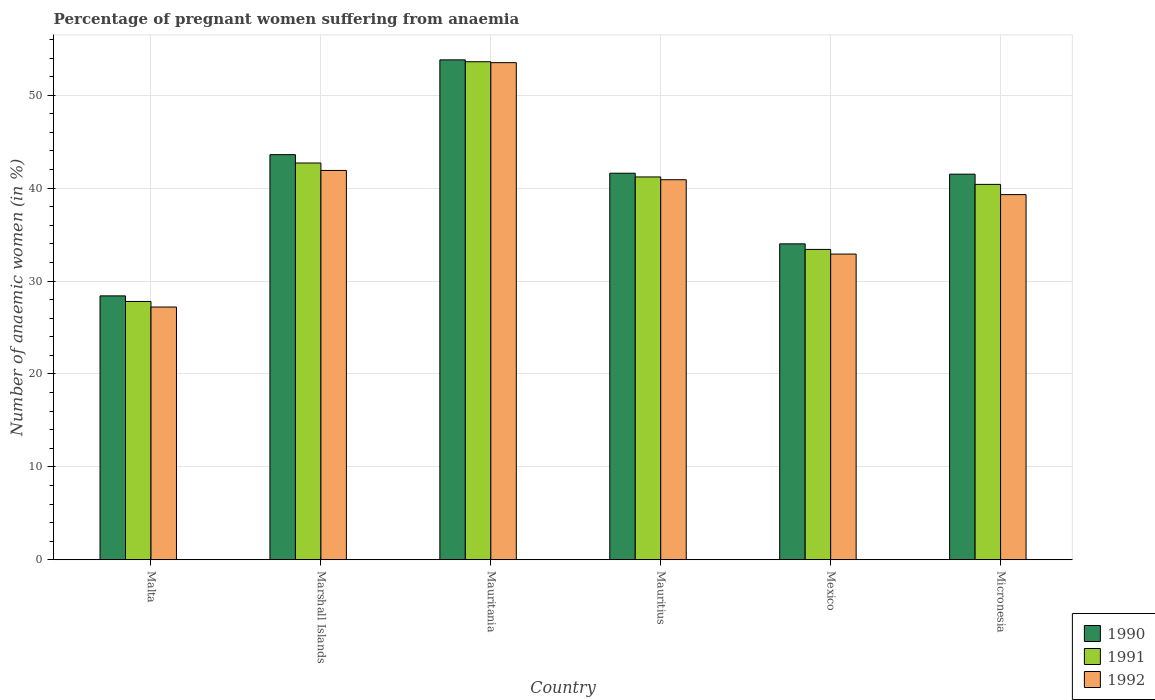How many different coloured bars are there?
Give a very brief answer. 3. Are the number of bars on each tick of the X-axis equal?
Provide a short and direct response. Yes. How many bars are there on the 6th tick from the right?
Ensure brevity in your answer.  3. What is the label of the 1st group of bars from the left?
Ensure brevity in your answer.  Malta. In how many cases, is the number of bars for a given country not equal to the number of legend labels?
Your response must be concise. 0. What is the number of anaemic women in 1991 in Micronesia?
Offer a very short reply. 40.4. Across all countries, what is the maximum number of anaemic women in 1990?
Make the answer very short. 53.8. Across all countries, what is the minimum number of anaemic women in 1992?
Give a very brief answer. 27.2. In which country was the number of anaemic women in 1991 maximum?
Offer a very short reply. Mauritania. In which country was the number of anaemic women in 1990 minimum?
Provide a short and direct response. Malta. What is the total number of anaemic women in 1992 in the graph?
Your answer should be compact. 235.7. What is the difference between the number of anaemic women in 1991 in Malta and that in Mauritius?
Your answer should be very brief. -13.4. What is the difference between the number of anaemic women in 1992 in Marshall Islands and the number of anaemic women in 1990 in Mauritius?
Offer a very short reply. 0.3. What is the average number of anaemic women in 1991 per country?
Offer a very short reply. 39.85. What is the difference between the number of anaemic women of/in 1990 and number of anaemic women of/in 1992 in Malta?
Ensure brevity in your answer.  1.2. In how many countries, is the number of anaemic women in 1991 greater than 40 %?
Your answer should be compact. 4. What is the ratio of the number of anaemic women in 1992 in Mexico to that in Micronesia?
Your response must be concise. 0.84. Is the difference between the number of anaemic women in 1990 in Malta and Marshall Islands greater than the difference between the number of anaemic women in 1992 in Malta and Marshall Islands?
Your answer should be very brief. No. What is the difference between the highest and the second highest number of anaemic women in 1991?
Give a very brief answer. -1.5. What is the difference between the highest and the lowest number of anaemic women in 1991?
Keep it short and to the point. 25.8. What does the 3rd bar from the left in Micronesia represents?
Your answer should be compact. 1992. What does the 2nd bar from the right in Mexico represents?
Your response must be concise. 1991. Are all the bars in the graph horizontal?
Your answer should be very brief. No. Does the graph contain any zero values?
Your answer should be very brief. No. How are the legend labels stacked?
Provide a short and direct response. Vertical. What is the title of the graph?
Provide a succinct answer. Percentage of pregnant women suffering from anaemia. What is the label or title of the X-axis?
Your answer should be compact. Country. What is the label or title of the Y-axis?
Offer a very short reply. Number of anaemic women (in %). What is the Number of anaemic women (in %) of 1990 in Malta?
Ensure brevity in your answer.  28.4. What is the Number of anaemic women (in %) of 1991 in Malta?
Your response must be concise. 27.8. What is the Number of anaemic women (in %) in 1992 in Malta?
Your answer should be compact. 27.2. What is the Number of anaemic women (in %) in 1990 in Marshall Islands?
Give a very brief answer. 43.6. What is the Number of anaemic women (in %) of 1991 in Marshall Islands?
Your answer should be very brief. 42.7. What is the Number of anaemic women (in %) in 1992 in Marshall Islands?
Keep it short and to the point. 41.9. What is the Number of anaemic women (in %) in 1990 in Mauritania?
Your answer should be very brief. 53.8. What is the Number of anaemic women (in %) in 1991 in Mauritania?
Your answer should be very brief. 53.6. What is the Number of anaemic women (in %) in 1992 in Mauritania?
Provide a succinct answer. 53.5. What is the Number of anaemic women (in %) of 1990 in Mauritius?
Provide a short and direct response. 41.6. What is the Number of anaemic women (in %) in 1991 in Mauritius?
Keep it short and to the point. 41.2. What is the Number of anaemic women (in %) in 1992 in Mauritius?
Offer a terse response. 40.9. What is the Number of anaemic women (in %) of 1990 in Mexico?
Your response must be concise. 34. What is the Number of anaemic women (in %) in 1991 in Mexico?
Offer a very short reply. 33.4. What is the Number of anaemic women (in %) in 1992 in Mexico?
Offer a terse response. 32.9. What is the Number of anaemic women (in %) in 1990 in Micronesia?
Keep it short and to the point. 41.5. What is the Number of anaemic women (in %) of 1991 in Micronesia?
Your response must be concise. 40.4. What is the Number of anaemic women (in %) in 1992 in Micronesia?
Keep it short and to the point. 39.3. Across all countries, what is the maximum Number of anaemic women (in %) of 1990?
Your answer should be compact. 53.8. Across all countries, what is the maximum Number of anaemic women (in %) in 1991?
Make the answer very short. 53.6. Across all countries, what is the maximum Number of anaemic women (in %) in 1992?
Keep it short and to the point. 53.5. Across all countries, what is the minimum Number of anaemic women (in %) in 1990?
Your answer should be compact. 28.4. Across all countries, what is the minimum Number of anaemic women (in %) of 1991?
Your answer should be very brief. 27.8. Across all countries, what is the minimum Number of anaemic women (in %) in 1992?
Provide a succinct answer. 27.2. What is the total Number of anaemic women (in %) in 1990 in the graph?
Offer a very short reply. 242.9. What is the total Number of anaemic women (in %) of 1991 in the graph?
Make the answer very short. 239.1. What is the total Number of anaemic women (in %) in 1992 in the graph?
Offer a terse response. 235.7. What is the difference between the Number of anaemic women (in %) in 1990 in Malta and that in Marshall Islands?
Make the answer very short. -15.2. What is the difference between the Number of anaemic women (in %) of 1991 in Malta and that in Marshall Islands?
Offer a very short reply. -14.9. What is the difference between the Number of anaemic women (in %) in 1992 in Malta and that in Marshall Islands?
Make the answer very short. -14.7. What is the difference between the Number of anaemic women (in %) of 1990 in Malta and that in Mauritania?
Provide a succinct answer. -25.4. What is the difference between the Number of anaemic women (in %) of 1991 in Malta and that in Mauritania?
Your answer should be very brief. -25.8. What is the difference between the Number of anaemic women (in %) of 1992 in Malta and that in Mauritania?
Your answer should be compact. -26.3. What is the difference between the Number of anaemic women (in %) of 1992 in Malta and that in Mauritius?
Your answer should be compact. -13.7. What is the difference between the Number of anaemic women (in %) in 1990 in Malta and that in Mexico?
Give a very brief answer. -5.6. What is the difference between the Number of anaemic women (in %) in 1991 in Malta and that in Mexico?
Your answer should be very brief. -5.6. What is the difference between the Number of anaemic women (in %) of 1992 in Malta and that in Mexico?
Provide a short and direct response. -5.7. What is the difference between the Number of anaemic women (in %) of 1991 in Malta and that in Micronesia?
Provide a succinct answer. -12.6. What is the difference between the Number of anaemic women (in %) in 1992 in Marshall Islands and that in Mauritania?
Ensure brevity in your answer.  -11.6. What is the difference between the Number of anaemic women (in %) in 1991 in Marshall Islands and that in Mauritius?
Keep it short and to the point. 1.5. What is the difference between the Number of anaemic women (in %) of 1992 in Marshall Islands and that in Mauritius?
Make the answer very short. 1. What is the difference between the Number of anaemic women (in %) in 1990 in Marshall Islands and that in Mexico?
Ensure brevity in your answer.  9.6. What is the difference between the Number of anaemic women (in %) of 1991 in Marshall Islands and that in Mexico?
Offer a very short reply. 9.3. What is the difference between the Number of anaemic women (in %) of 1990 in Marshall Islands and that in Micronesia?
Offer a very short reply. 2.1. What is the difference between the Number of anaemic women (in %) in 1991 in Marshall Islands and that in Micronesia?
Provide a short and direct response. 2.3. What is the difference between the Number of anaemic women (in %) in 1990 in Mauritania and that in Mauritius?
Make the answer very short. 12.2. What is the difference between the Number of anaemic women (in %) in 1991 in Mauritania and that in Mauritius?
Provide a succinct answer. 12.4. What is the difference between the Number of anaemic women (in %) in 1992 in Mauritania and that in Mauritius?
Provide a succinct answer. 12.6. What is the difference between the Number of anaemic women (in %) in 1990 in Mauritania and that in Mexico?
Offer a terse response. 19.8. What is the difference between the Number of anaemic women (in %) in 1991 in Mauritania and that in Mexico?
Offer a very short reply. 20.2. What is the difference between the Number of anaemic women (in %) in 1992 in Mauritania and that in Mexico?
Your answer should be compact. 20.6. What is the difference between the Number of anaemic women (in %) of 1991 in Mauritius and that in Micronesia?
Your answer should be very brief. 0.8. What is the difference between the Number of anaemic women (in %) in 1992 in Mauritius and that in Micronesia?
Offer a very short reply. 1.6. What is the difference between the Number of anaemic women (in %) of 1990 in Mexico and that in Micronesia?
Offer a terse response. -7.5. What is the difference between the Number of anaemic women (in %) in 1991 in Mexico and that in Micronesia?
Your response must be concise. -7. What is the difference between the Number of anaemic women (in %) in 1992 in Mexico and that in Micronesia?
Your answer should be compact. -6.4. What is the difference between the Number of anaemic women (in %) in 1990 in Malta and the Number of anaemic women (in %) in 1991 in Marshall Islands?
Ensure brevity in your answer.  -14.3. What is the difference between the Number of anaemic women (in %) of 1991 in Malta and the Number of anaemic women (in %) of 1992 in Marshall Islands?
Offer a very short reply. -14.1. What is the difference between the Number of anaemic women (in %) of 1990 in Malta and the Number of anaemic women (in %) of 1991 in Mauritania?
Offer a terse response. -25.2. What is the difference between the Number of anaemic women (in %) in 1990 in Malta and the Number of anaemic women (in %) in 1992 in Mauritania?
Keep it short and to the point. -25.1. What is the difference between the Number of anaemic women (in %) of 1991 in Malta and the Number of anaemic women (in %) of 1992 in Mauritania?
Your response must be concise. -25.7. What is the difference between the Number of anaemic women (in %) of 1990 in Malta and the Number of anaemic women (in %) of 1991 in Mauritius?
Offer a terse response. -12.8. What is the difference between the Number of anaemic women (in %) of 1990 in Malta and the Number of anaemic women (in %) of 1992 in Mauritius?
Your response must be concise. -12.5. What is the difference between the Number of anaemic women (in %) of 1991 in Malta and the Number of anaemic women (in %) of 1992 in Mauritius?
Make the answer very short. -13.1. What is the difference between the Number of anaemic women (in %) of 1990 in Malta and the Number of anaemic women (in %) of 1991 in Mexico?
Ensure brevity in your answer.  -5. What is the difference between the Number of anaemic women (in %) of 1990 in Malta and the Number of anaemic women (in %) of 1992 in Mexico?
Provide a succinct answer. -4.5. What is the difference between the Number of anaemic women (in %) in 1990 in Malta and the Number of anaemic women (in %) in 1992 in Micronesia?
Ensure brevity in your answer.  -10.9. What is the difference between the Number of anaemic women (in %) in 1991 in Marshall Islands and the Number of anaemic women (in %) in 1992 in Mauritania?
Provide a succinct answer. -10.8. What is the difference between the Number of anaemic women (in %) in 1990 in Marshall Islands and the Number of anaemic women (in %) in 1992 in Mauritius?
Your response must be concise. 2.7. What is the difference between the Number of anaemic women (in %) of 1991 in Marshall Islands and the Number of anaemic women (in %) of 1992 in Mauritius?
Provide a short and direct response. 1.8. What is the difference between the Number of anaemic women (in %) of 1990 in Marshall Islands and the Number of anaemic women (in %) of 1991 in Mexico?
Offer a terse response. 10.2. What is the difference between the Number of anaemic women (in %) in 1991 in Marshall Islands and the Number of anaemic women (in %) in 1992 in Mexico?
Offer a terse response. 9.8. What is the difference between the Number of anaemic women (in %) in 1990 in Marshall Islands and the Number of anaemic women (in %) in 1991 in Micronesia?
Provide a short and direct response. 3.2. What is the difference between the Number of anaemic women (in %) in 1990 in Marshall Islands and the Number of anaemic women (in %) in 1992 in Micronesia?
Provide a short and direct response. 4.3. What is the difference between the Number of anaemic women (in %) of 1991 in Marshall Islands and the Number of anaemic women (in %) of 1992 in Micronesia?
Ensure brevity in your answer.  3.4. What is the difference between the Number of anaemic women (in %) of 1990 in Mauritania and the Number of anaemic women (in %) of 1991 in Mexico?
Keep it short and to the point. 20.4. What is the difference between the Number of anaemic women (in %) of 1990 in Mauritania and the Number of anaemic women (in %) of 1992 in Mexico?
Your answer should be compact. 20.9. What is the difference between the Number of anaemic women (in %) in 1991 in Mauritania and the Number of anaemic women (in %) in 1992 in Mexico?
Make the answer very short. 20.7. What is the difference between the Number of anaemic women (in %) in 1990 in Mauritania and the Number of anaemic women (in %) in 1991 in Micronesia?
Offer a terse response. 13.4. What is the difference between the Number of anaemic women (in %) in 1990 in Mauritania and the Number of anaemic women (in %) in 1992 in Micronesia?
Make the answer very short. 14.5. What is the difference between the Number of anaemic women (in %) in 1990 in Mauritius and the Number of anaemic women (in %) in 1991 in Mexico?
Provide a succinct answer. 8.2. What is the difference between the Number of anaemic women (in %) of 1990 in Mauritius and the Number of anaemic women (in %) of 1991 in Micronesia?
Your response must be concise. 1.2. What is the difference between the Number of anaemic women (in %) in 1990 in Mauritius and the Number of anaemic women (in %) in 1992 in Micronesia?
Your answer should be compact. 2.3. What is the difference between the Number of anaemic women (in %) of 1991 in Mauritius and the Number of anaemic women (in %) of 1992 in Micronesia?
Make the answer very short. 1.9. What is the average Number of anaemic women (in %) of 1990 per country?
Give a very brief answer. 40.48. What is the average Number of anaemic women (in %) in 1991 per country?
Your answer should be very brief. 39.85. What is the average Number of anaemic women (in %) of 1992 per country?
Keep it short and to the point. 39.28. What is the difference between the Number of anaemic women (in %) of 1990 and Number of anaemic women (in %) of 1991 in Malta?
Make the answer very short. 0.6. What is the difference between the Number of anaemic women (in %) of 1990 and Number of anaemic women (in %) of 1992 in Malta?
Ensure brevity in your answer.  1.2. What is the difference between the Number of anaemic women (in %) in 1990 and Number of anaemic women (in %) in 1992 in Marshall Islands?
Provide a succinct answer. 1.7. What is the difference between the Number of anaemic women (in %) in 1990 and Number of anaemic women (in %) in 1991 in Mauritania?
Provide a succinct answer. 0.2. What is the difference between the Number of anaemic women (in %) in 1990 and Number of anaemic women (in %) in 1992 in Mauritania?
Provide a succinct answer. 0.3. What is the difference between the Number of anaemic women (in %) in 1991 and Number of anaemic women (in %) in 1992 in Mauritania?
Give a very brief answer. 0.1. What is the difference between the Number of anaemic women (in %) in 1990 and Number of anaemic women (in %) in 1991 in Mexico?
Ensure brevity in your answer.  0.6. What is the difference between the Number of anaemic women (in %) of 1990 and Number of anaemic women (in %) of 1992 in Mexico?
Your answer should be compact. 1.1. What is the difference between the Number of anaemic women (in %) of 1991 and Number of anaemic women (in %) of 1992 in Micronesia?
Your answer should be compact. 1.1. What is the ratio of the Number of anaemic women (in %) of 1990 in Malta to that in Marshall Islands?
Ensure brevity in your answer.  0.65. What is the ratio of the Number of anaemic women (in %) of 1991 in Malta to that in Marshall Islands?
Offer a very short reply. 0.65. What is the ratio of the Number of anaemic women (in %) of 1992 in Malta to that in Marshall Islands?
Offer a terse response. 0.65. What is the ratio of the Number of anaemic women (in %) of 1990 in Malta to that in Mauritania?
Provide a short and direct response. 0.53. What is the ratio of the Number of anaemic women (in %) of 1991 in Malta to that in Mauritania?
Give a very brief answer. 0.52. What is the ratio of the Number of anaemic women (in %) in 1992 in Malta to that in Mauritania?
Give a very brief answer. 0.51. What is the ratio of the Number of anaemic women (in %) in 1990 in Malta to that in Mauritius?
Keep it short and to the point. 0.68. What is the ratio of the Number of anaemic women (in %) in 1991 in Malta to that in Mauritius?
Provide a succinct answer. 0.67. What is the ratio of the Number of anaemic women (in %) of 1992 in Malta to that in Mauritius?
Your answer should be very brief. 0.67. What is the ratio of the Number of anaemic women (in %) of 1990 in Malta to that in Mexico?
Your response must be concise. 0.84. What is the ratio of the Number of anaemic women (in %) of 1991 in Malta to that in Mexico?
Provide a short and direct response. 0.83. What is the ratio of the Number of anaemic women (in %) of 1992 in Malta to that in Mexico?
Ensure brevity in your answer.  0.83. What is the ratio of the Number of anaemic women (in %) of 1990 in Malta to that in Micronesia?
Your answer should be very brief. 0.68. What is the ratio of the Number of anaemic women (in %) in 1991 in Malta to that in Micronesia?
Offer a very short reply. 0.69. What is the ratio of the Number of anaemic women (in %) of 1992 in Malta to that in Micronesia?
Your answer should be compact. 0.69. What is the ratio of the Number of anaemic women (in %) in 1990 in Marshall Islands to that in Mauritania?
Provide a short and direct response. 0.81. What is the ratio of the Number of anaemic women (in %) in 1991 in Marshall Islands to that in Mauritania?
Your answer should be very brief. 0.8. What is the ratio of the Number of anaemic women (in %) in 1992 in Marshall Islands to that in Mauritania?
Give a very brief answer. 0.78. What is the ratio of the Number of anaemic women (in %) of 1990 in Marshall Islands to that in Mauritius?
Keep it short and to the point. 1.05. What is the ratio of the Number of anaemic women (in %) in 1991 in Marshall Islands to that in Mauritius?
Offer a very short reply. 1.04. What is the ratio of the Number of anaemic women (in %) in 1992 in Marshall Islands to that in Mauritius?
Offer a terse response. 1.02. What is the ratio of the Number of anaemic women (in %) in 1990 in Marshall Islands to that in Mexico?
Your answer should be very brief. 1.28. What is the ratio of the Number of anaemic women (in %) of 1991 in Marshall Islands to that in Mexico?
Make the answer very short. 1.28. What is the ratio of the Number of anaemic women (in %) of 1992 in Marshall Islands to that in Mexico?
Ensure brevity in your answer.  1.27. What is the ratio of the Number of anaemic women (in %) of 1990 in Marshall Islands to that in Micronesia?
Your response must be concise. 1.05. What is the ratio of the Number of anaemic women (in %) of 1991 in Marshall Islands to that in Micronesia?
Your response must be concise. 1.06. What is the ratio of the Number of anaemic women (in %) in 1992 in Marshall Islands to that in Micronesia?
Ensure brevity in your answer.  1.07. What is the ratio of the Number of anaemic women (in %) in 1990 in Mauritania to that in Mauritius?
Provide a short and direct response. 1.29. What is the ratio of the Number of anaemic women (in %) in 1991 in Mauritania to that in Mauritius?
Provide a short and direct response. 1.3. What is the ratio of the Number of anaemic women (in %) in 1992 in Mauritania to that in Mauritius?
Ensure brevity in your answer.  1.31. What is the ratio of the Number of anaemic women (in %) in 1990 in Mauritania to that in Mexico?
Ensure brevity in your answer.  1.58. What is the ratio of the Number of anaemic women (in %) of 1991 in Mauritania to that in Mexico?
Make the answer very short. 1.6. What is the ratio of the Number of anaemic women (in %) of 1992 in Mauritania to that in Mexico?
Offer a terse response. 1.63. What is the ratio of the Number of anaemic women (in %) in 1990 in Mauritania to that in Micronesia?
Give a very brief answer. 1.3. What is the ratio of the Number of anaemic women (in %) of 1991 in Mauritania to that in Micronesia?
Ensure brevity in your answer.  1.33. What is the ratio of the Number of anaemic women (in %) in 1992 in Mauritania to that in Micronesia?
Give a very brief answer. 1.36. What is the ratio of the Number of anaemic women (in %) of 1990 in Mauritius to that in Mexico?
Give a very brief answer. 1.22. What is the ratio of the Number of anaemic women (in %) in 1991 in Mauritius to that in Mexico?
Offer a terse response. 1.23. What is the ratio of the Number of anaemic women (in %) in 1992 in Mauritius to that in Mexico?
Your answer should be compact. 1.24. What is the ratio of the Number of anaemic women (in %) of 1990 in Mauritius to that in Micronesia?
Ensure brevity in your answer.  1. What is the ratio of the Number of anaemic women (in %) in 1991 in Mauritius to that in Micronesia?
Provide a succinct answer. 1.02. What is the ratio of the Number of anaemic women (in %) of 1992 in Mauritius to that in Micronesia?
Provide a succinct answer. 1.04. What is the ratio of the Number of anaemic women (in %) of 1990 in Mexico to that in Micronesia?
Offer a terse response. 0.82. What is the ratio of the Number of anaemic women (in %) of 1991 in Mexico to that in Micronesia?
Keep it short and to the point. 0.83. What is the ratio of the Number of anaemic women (in %) of 1992 in Mexico to that in Micronesia?
Offer a terse response. 0.84. What is the difference between the highest and the second highest Number of anaemic women (in %) in 1991?
Keep it short and to the point. 10.9. What is the difference between the highest and the lowest Number of anaemic women (in %) of 1990?
Offer a very short reply. 25.4. What is the difference between the highest and the lowest Number of anaemic women (in %) of 1991?
Your answer should be very brief. 25.8. What is the difference between the highest and the lowest Number of anaemic women (in %) in 1992?
Your response must be concise. 26.3. 